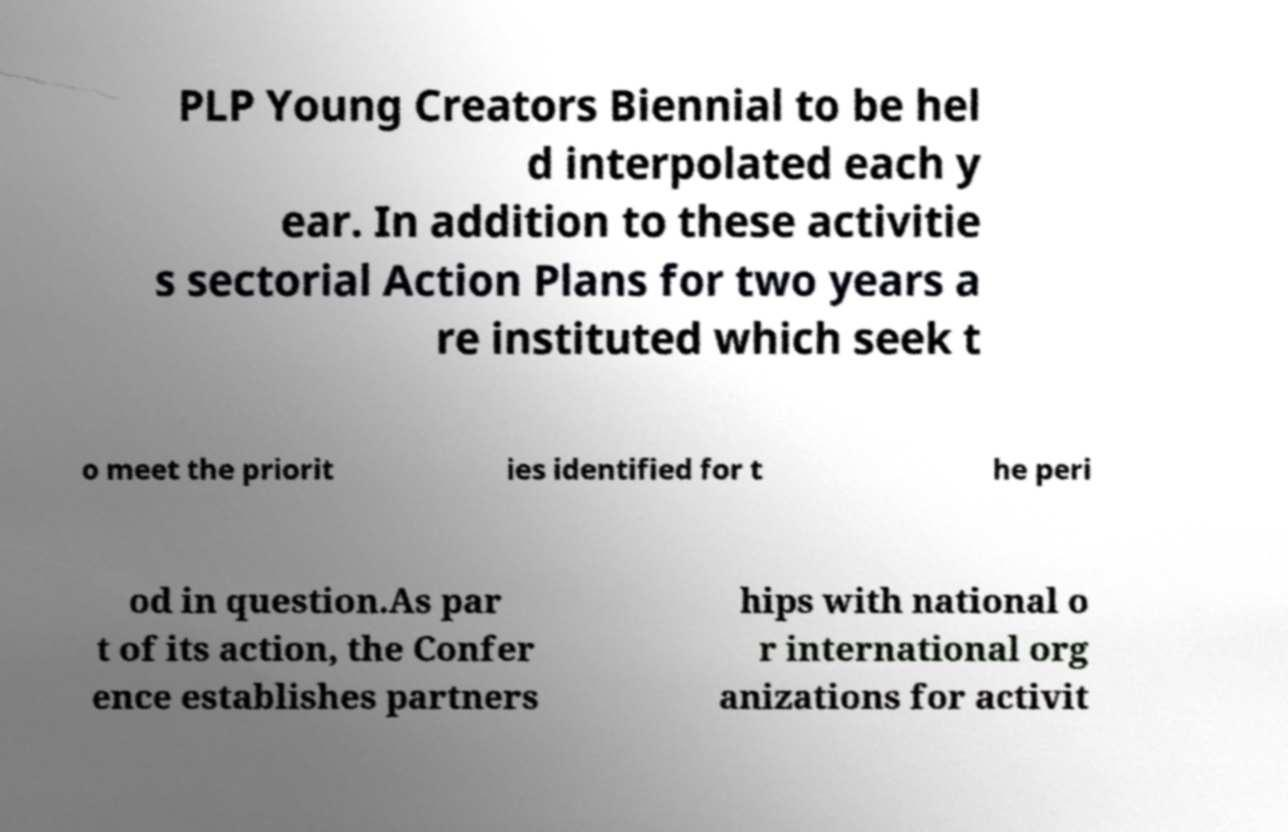Can you accurately transcribe the text from the provided image for me? PLP Young Creators Biennial to be hel d interpolated each y ear. In addition to these activitie s sectorial Action Plans for two years a re instituted which seek t o meet the priorit ies identified for t he peri od in question.As par t of its action, the Confer ence establishes partners hips with national o r international org anizations for activit 